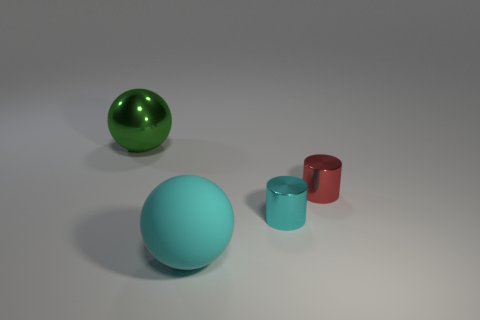Can you tell the material these objects could be made of? The objects in the image have a shiny, smooth texture suggesting they could be made of a reflective material such as plastic or polished metal. 